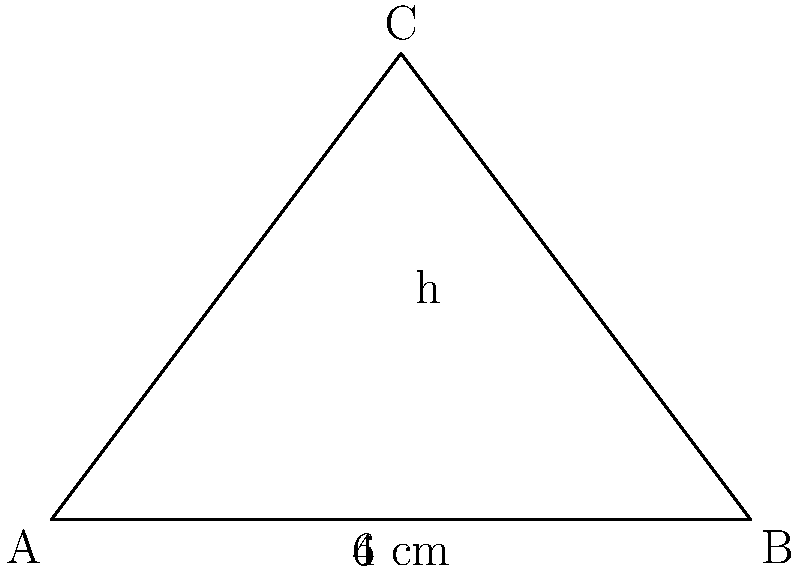You are designing a triangular LED display panel for your chess-playing robot. The base of the panel is 6 cm, and the height is 4 cm. What is the area of this triangular display in square centimeters? To find the area of a triangle, we use the formula:

$$ A = \frac{1}{2} \times base \times height $$

Given:
- Base (b) = 6 cm
- Height (h) = 4 cm

Let's substitute these values into the formula:

$$ A = \frac{1}{2} \times 6 \text{ cm} \times 4 \text{ cm} $$

$$ A = \frac{1}{2} \times 24 \text{ cm}^2 $$

$$ A = 12 \text{ cm}^2 $$

Therefore, the area of the triangular LED display panel is 12 square centimeters.
Answer: 12 cm² 